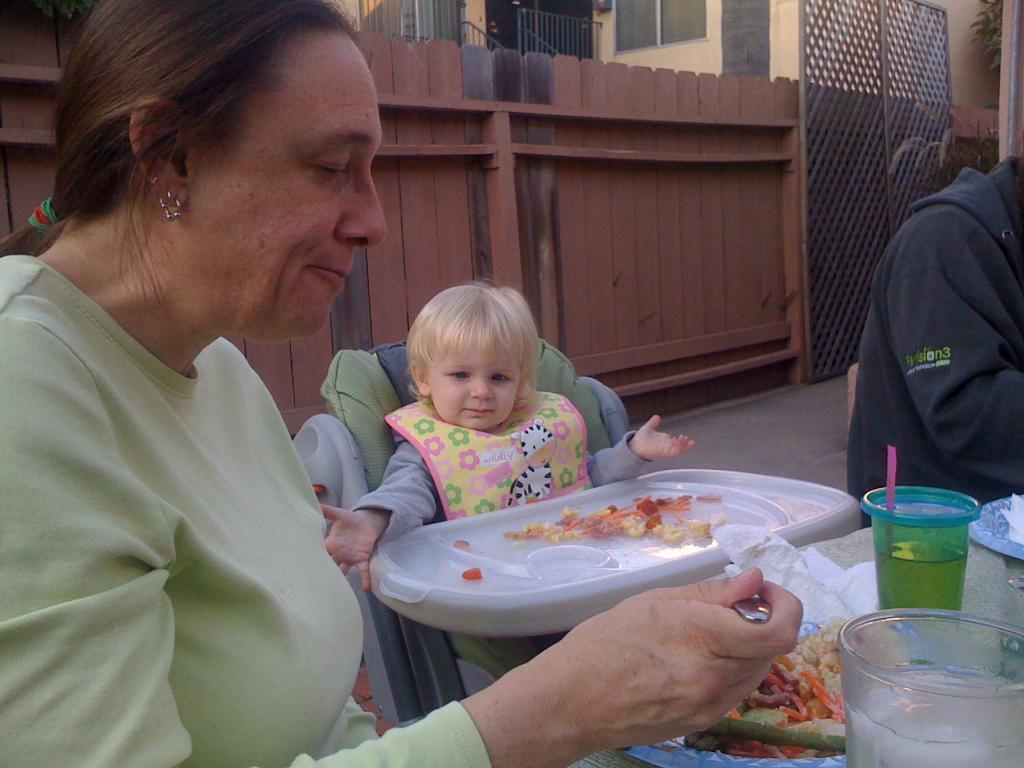Describe this image in one or two sentences. In this image I can see a woman wearing green colored dress is holding a spoon in her hand. I can see a child and another person sitting. I can see a table in front of them and on the table I can see few plates with food items in them and few glasses. In the background I can see the wooden railing and few buildings. 